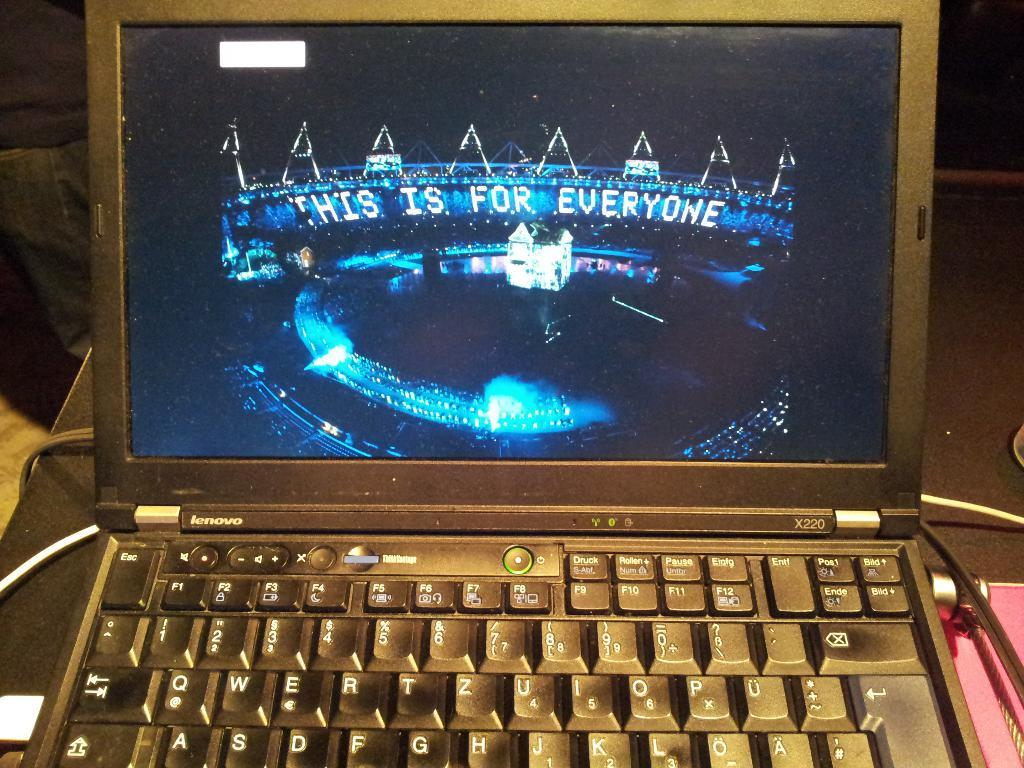<image>
Write a terse but informative summary of the picture. A laptop computer which is powered on and shows a stage with the words This is for Everyone. 